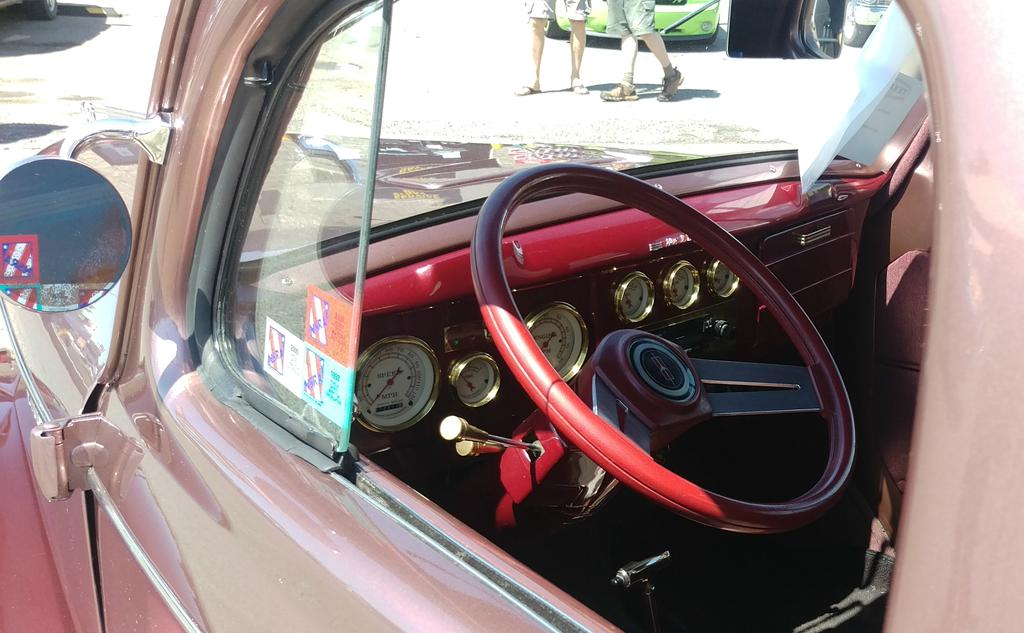What is the main subject of the image? The main subject of the image is a car. What features can be seen inside the car? The car has a steering wheel and meters. What is present on the glass inside the car? There are posters on the glass inside the car. Can you describe the surroundings of the car in the image? Two people's legs are visible behind the car, and there are other cars on the ground in the image. What type of plastic material can be seen in the car's nest in the image? There is no plastic material or nest present in the image; it features a car with people's legs and other cars on the ground. 